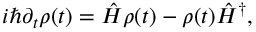<formula> <loc_0><loc_0><loc_500><loc_500>\begin{array} { r } { i \hbar { \partial } _ { t } \rho ( t ) = \hat { H } \rho ( t ) - \rho ( t ) \hat { H } ^ { \dag } , } \end{array}</formula> 